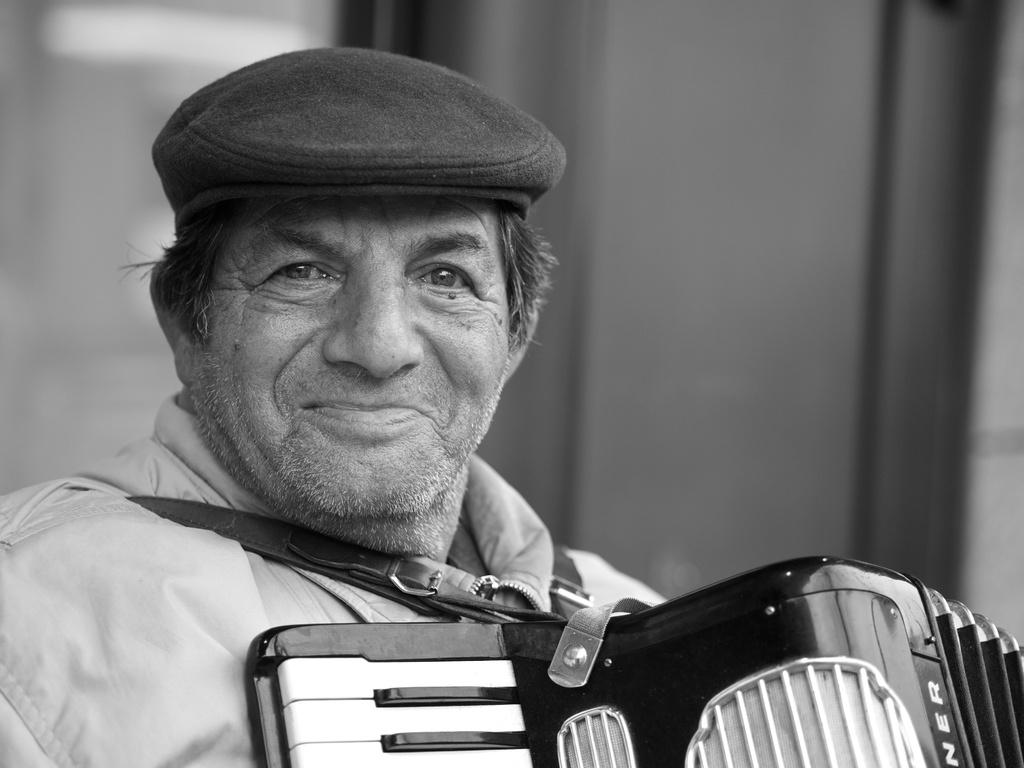What is the main subject of the image? There is a person in the image. What is the person doing in the image? The person is smiling. What accessory is the person wearing in the image? The person is wearing a cap. What other object can be seen in the image? There is a musical instrument in the image. How many rabbits are jumping over the musical instrument in the image? There are no rabbits present in the image, and therefore no rabbits are jumping over the musical instrument. 